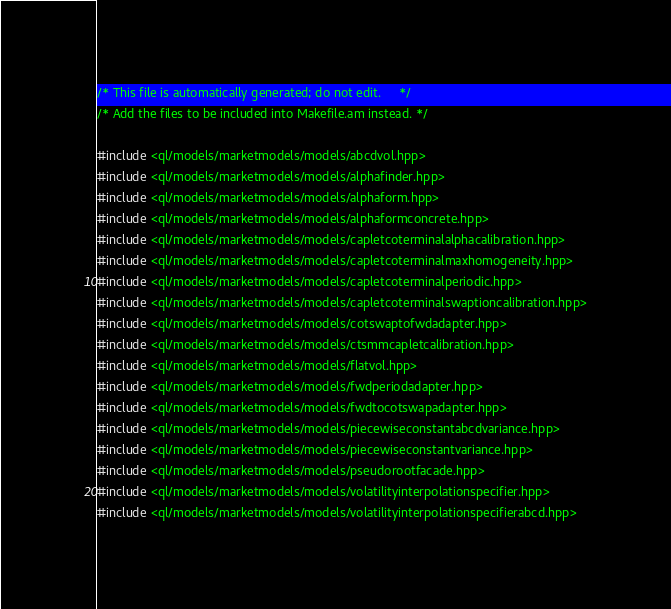Convert code to text. <code><loc_0><loc_0><loc_500><loc_500><_C++_>/* This file is automatically generated; do not edit.     */
/* Add the files to be included into Makefile.am instead. */

#include <ql/models/marketmodels/models/abcdvol.hpp>
#include <ql/models/marketmodels/models/alphafinder.hpp>
#include <ql/models/marketmodels/models/alphaform.hpp>
#include <ql/models/marketmodels/models/alphaformconcrete.hpp>
#include <ql/models/marketmodels/models/capletcoterminalalphacalibration.hpp>
#include <ql/models/marketmodels/models/capletcoterminalmaxhomogeneity.hpp>
#include <ql/models/marketmodels/models/capletcoterminalperiodic.hpp>
#include <ql/models/marketmodels/models/capletcoterminalswaptioncalibration.hpp>
#include <ql/models/marketmodels/models/cotswaptofwdadapter.hpp>
#include <ql/models/marketmodels/models/ctsmmcapletcalibration.hpp>
#include <ql/models/marketmodels/models/flatvol.hpp>
#include <ql/models/marketmodels/models/fwdperiodadapter.hpp>
#include <ql/models/marketmodels/models/fwdtocotswapadapter.hpp>
#include <ql/models/marketmodels/models/piecewiseconstantabcdvariance.hpp>
#include <ql/models/marketmodels/models/piecewiseconstantvariance.hpp>
#include <ql/models/marketmodels/models/pseudorootfacade.hpp>
#include <ql/models/marketmodels/models/volatilityinterpolationspecifier.hpp>
#include <ql/models/marketmodels/models/volatilityinterpolationspecifierabcd.hpp>

</code> 